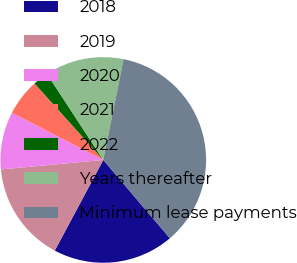<chart> <loc_0><loc_0><loc_500><loc_500><pie_chart><fcel>2018<fcel>2019<fcel>2020<fcel>2021<fcel>2022<fcel>Years thereafter<fcel>Minimum lease payments<nl><fcel>19.03%<fcel>15.71%<fcel>9.07%<fcel>5.75%<fcel>2.43%<fcel>12.39%<fcel>35.62%<nl></chart> 